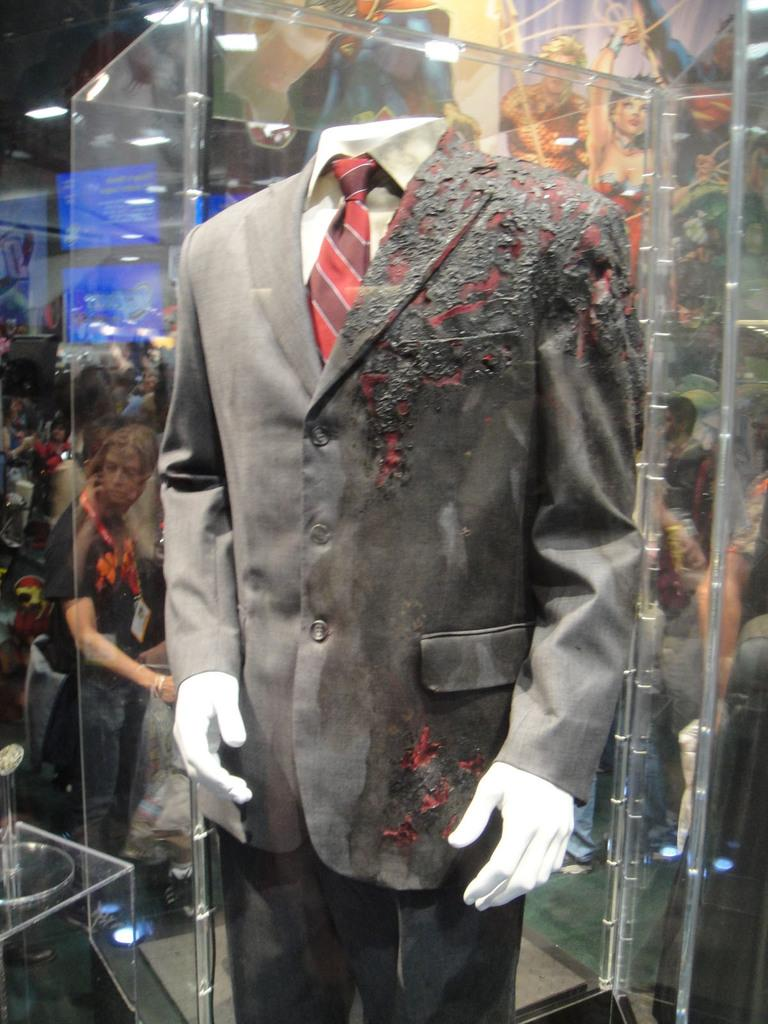What is the main subject of the image? There is a mannequin in the image. What is the mannequin wearing? The mannequin is wearing a suit. What is the condition of the suit? The suit is partially burnt. Can you describe the people in the background of the image? There are people in the background of the image, but their specific features or actions are not mentioned in the facts. What accessory is visible on the mannequin? There is a red tie visible in the image. How many cows are visible in the image? There are no cows present in the image. What type of comb is the mannequin using in the image? There is no comb visible in the image, and the mannequin is not using any comb. 